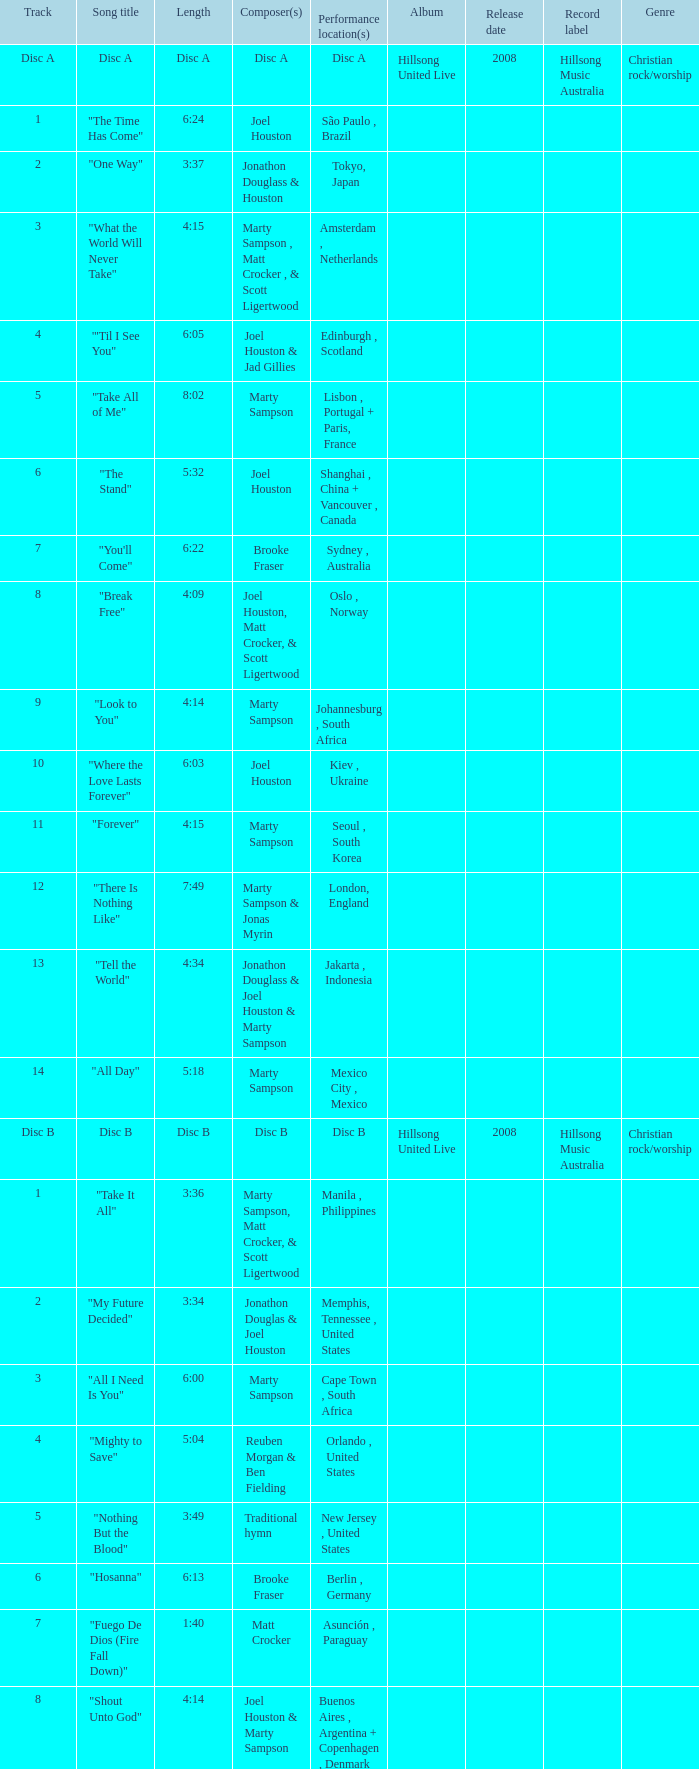Who is the composer of the song with a length of 6:24? Joel Houston. 